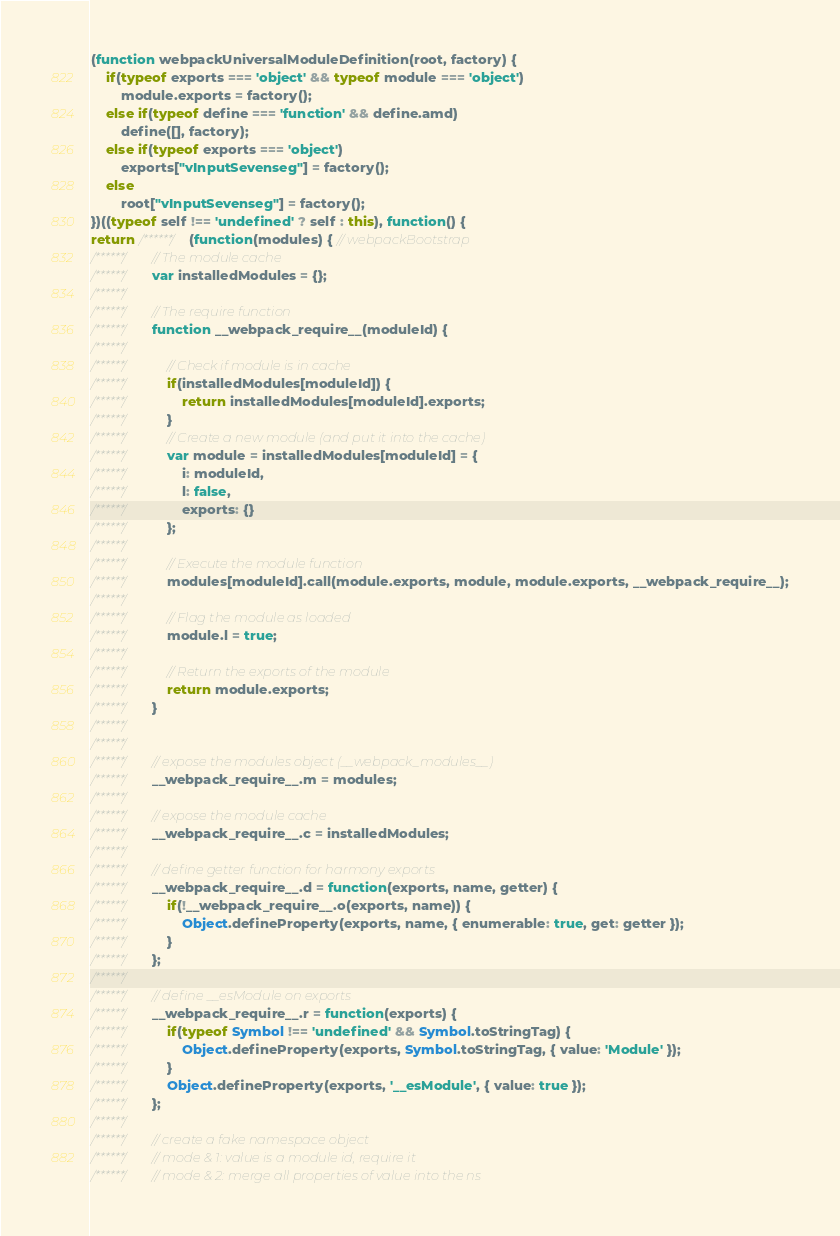Convert code to text. <code><loc_0><loc_0><loc_500><loc_500><_JavaScript_>(function webpackUniversalModuleDefinition(root, factory) {
	if(typeof exports === 'object' && typeof module === 'object')
		module.exports = factory();
	else if(typeof define === 'function' && define.amd)
		define([], factory);
	else if(typeof exports === 'object')
		exports["vInputSevenseg"] = factory();
	else
		root["vInputSevenseg"] = factory();
})((typeof self !== 'undefined' ? self : this), function() {
return /******/ (function(modules) { // webpackBootstrap
/******/ 	// The module cache
/******/ 	var installedModules = {};
/******/
/******/ 	// The require function
/******/ 	function __webpack_require__(moduleId) {
/******/
/******/ 		// Check if module is in cache
/******/ 		if(installedModules[moduleId]) {
/******/ 			return installedModules[moduleId].exports;
/******/ 		}
/******/ 		// Create a new module (and put it into the cache)
/******/ 		var module = installedModules[moduleId] = {
/******/ 			i: moduleId,
/******/ 			l: false,
/******/ 			exports: {}
/******/ 		};
/******/
/******/ 		// Execute the module function
/******/ 		modules[moduleId].call(module.exports, module, module.exports, __webpack_require__);
/******/
/******/ 		// Flag the module as loaded
/******/ 		module.l = true;
/******/
/******/ 		// Return the exports of the module
/******/ 		return module.exports;
/******/ 	}
/******/
/******/
/******/ 	// expose the modules object (__webpack_modules__)
/******/ 	__webpack_require__.m = modules;
/******/
/******/ 	// expose the module cache
/******/ 	__webpack_require__.c = installedModules;
/******/
/******/ 	// define getter function for harmony exports
/******/ 	__webpack_require__.d = function(exports, name, getter) {
/******/ 		if(!__webpack_require__.o(exports, name)) {
/******/ 			Object.defineProperty(exports, name, { enumerable: true, get: getter });
/******/ 		}
/******/ 	};
/******/
/******/ 	// define __esModule on exports
/******/ 	__webpack_require__.r = function(exports) {
/******/ 		if(typeof Symbol !== 'undefined' && Symbol.toStringTag) {
/******/ 			Object.defineProperty(exports, Symbol.toStringTag, { value: 'Module' });
/******/ 		}
/******/ 		Object.defineProperty(exports, '__esModule', { value: true });
/******/ 	};
/******/
/******/ 	// create a fake namespace object
/******/ 	// mode & 1: value is a module id, require it
/******/ 	// mode & 2: merge all properties of value into the ns</code> 